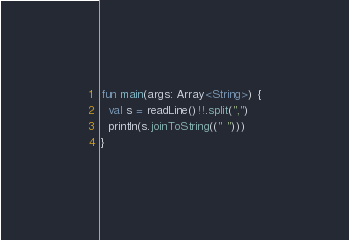<code> <loc_0><loc_0><loc_500><loc_500><_Kotlin_>fun main(args: Array<String>) {
  val s = readLine()!!.split(",")
  println(s.joinToString((" ")))
}</code> 